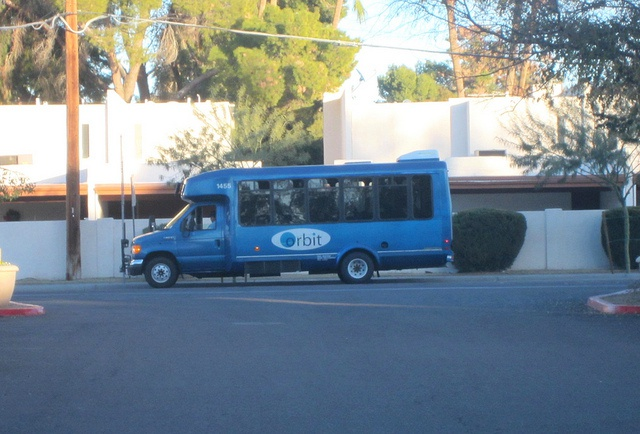Describe the objects in this image and their specific colors. I can see bus in tan, blue, navy, and black tones and people in tan, gray, and black tones in this image. 